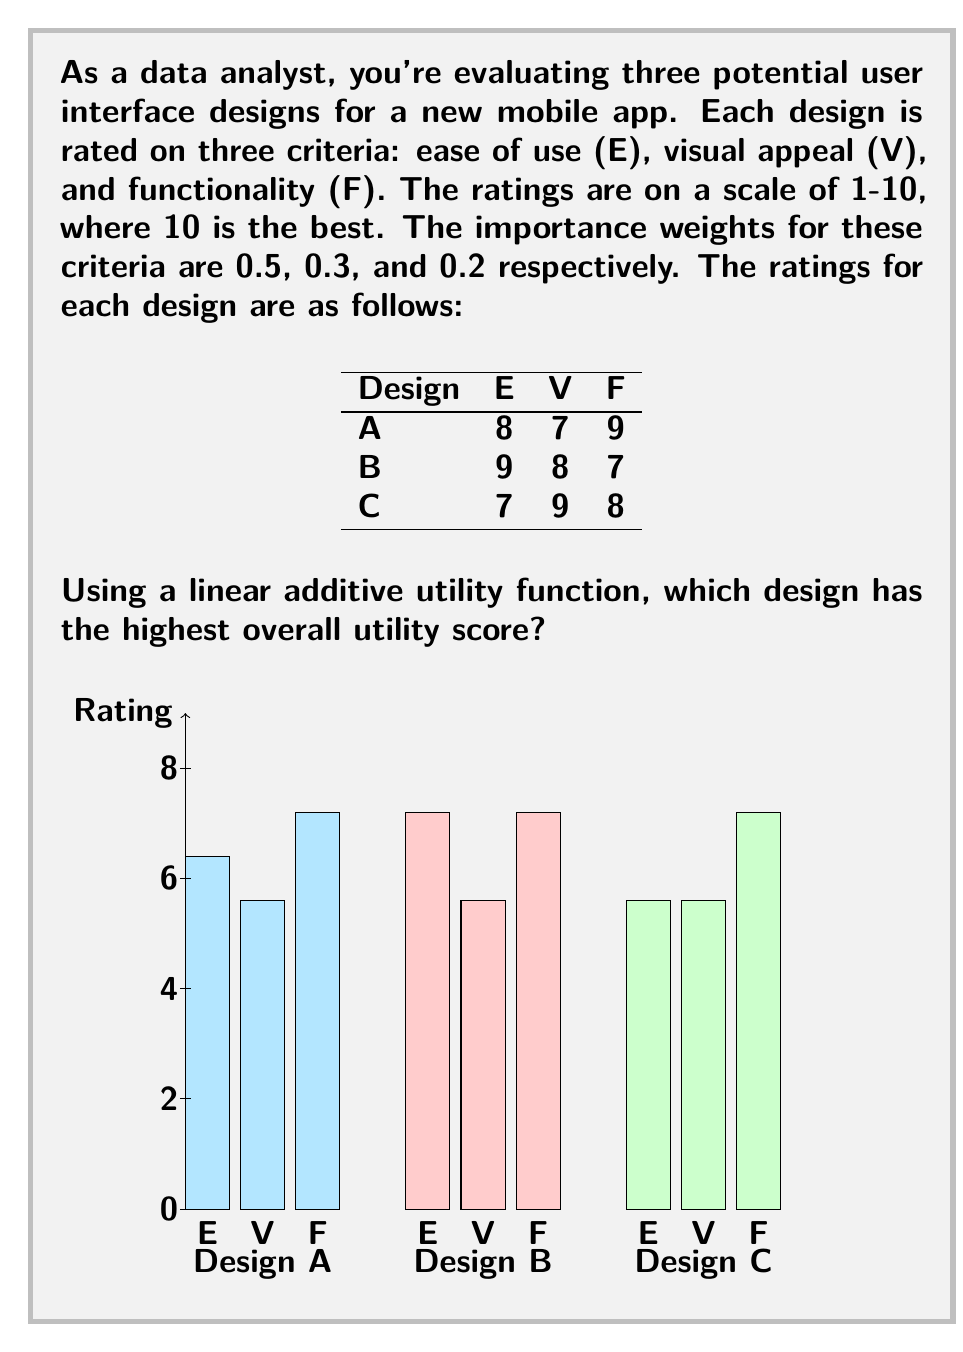Give your solution to this math problem. To solve this problem, we'll use a linear additive utility function to calculate the overall utility score for each design. The general form of this function is:

$$ U = \sum_{i=1}^n w_i \cdot x_i $$

Where:
$U$ is the overall utility score
$w_i$ is the weight of criterion $i$
$x_i$ is the rating for criterion $i$
$n$ is the number of criteria

Let's calculate the utility score for each design:

1. Design A:
   $$ U_A = 0.5 \cdot 8 + 0.3 \cdot 7 + 0.2 \cdot 9 $$
   $$ U_A = 4 + 2.1 + 1.8 = 7.9 $$

2. Design B:
   $$ U_B = 0.5 \cdot 9 + 0.3 \cdot 8 + 0.2 \cdot 7 $$
   $$ U_B = 4.5 + 2.4 + 1.4 = 8.3 $$

3. Design C:
   $$ U_C = 0.5 \cdot 7 + 0.3 \cdot 9 + 0.2 \cdot 8 $$
   $$ U_C = 3.5 + 2.7 + 1.6 = 7.8 $$

Comparing the utility scores:
$U_A = 7.9$
$U_B = 8.3$
$U_C = 7.8$

Design B has the highest overall utility score of 8.3.
Answer: Design B 